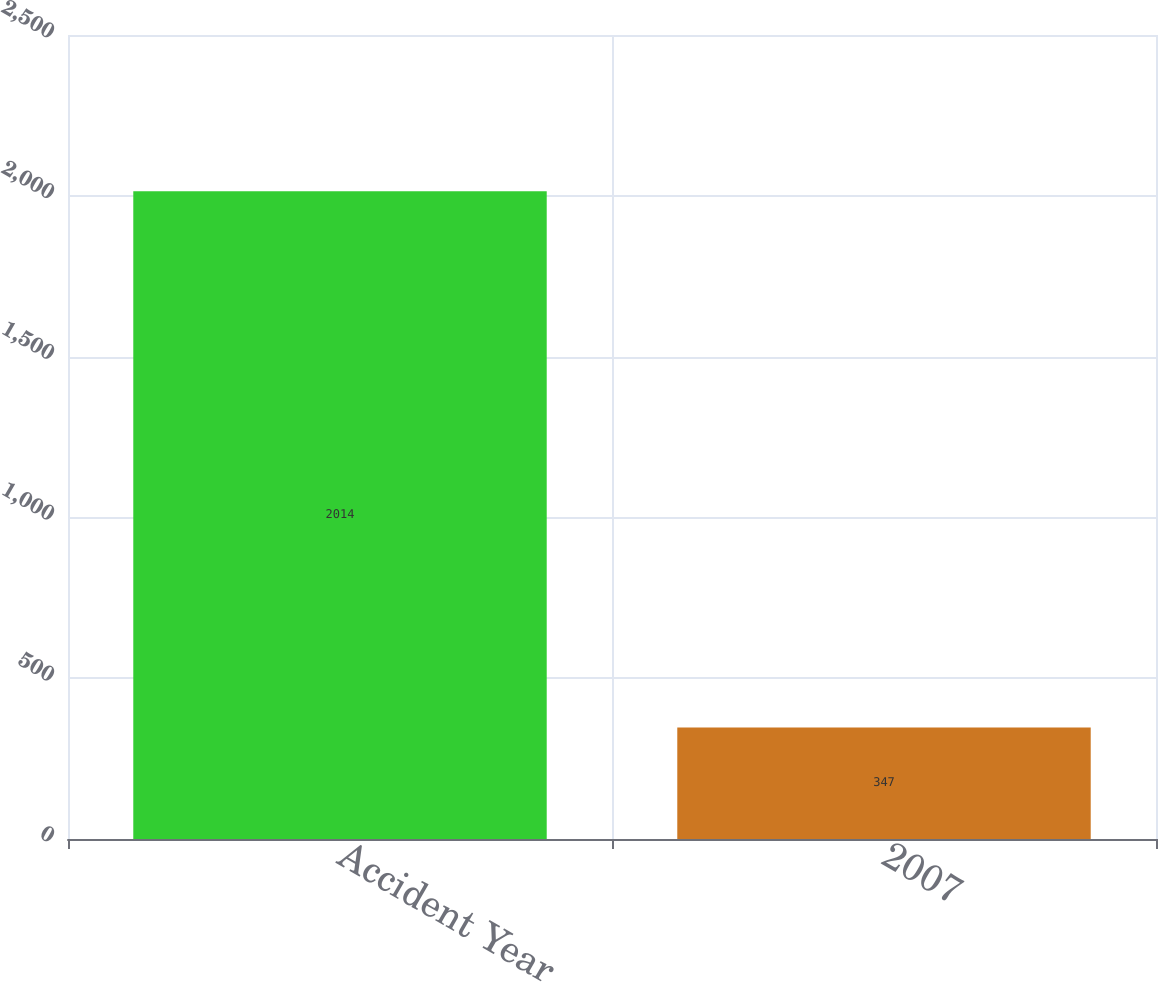Convert chart. <chart><loc_0><loc_0><loc_500><loc_500><bar_chart><fcel>Accident Year<fcel>2007<nl><fcel>2014<fcel>347<nl></chart> 